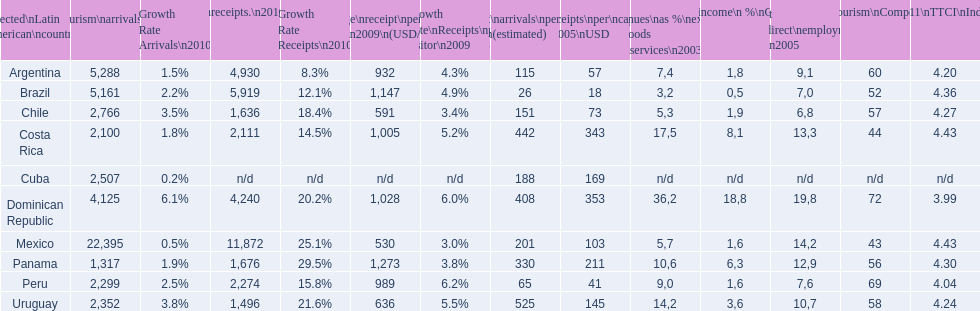What country ranks the best in most categories? Dominican Republic. 